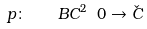<formula> <loc_0><loc_0><loc_500><loc_500>p \colon \quad B C ^ { 2 } \ 0 \rightarrow \check { C }</formula> 